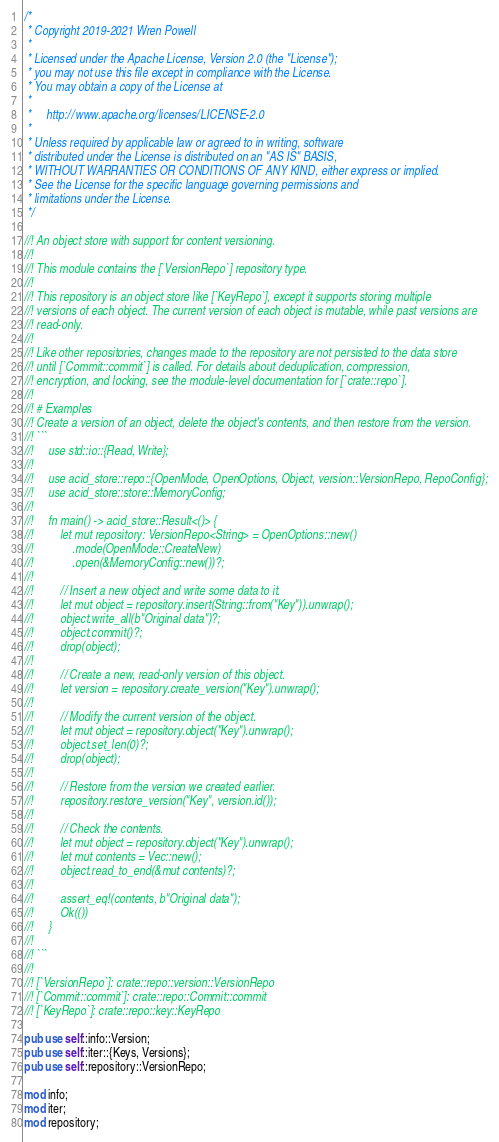Convert code to text. <code><loc_0><loc_0><loc_500><loc_500><_Rust_>/*
 * Copyright 2019-2021 Wren Powell
 *
 * Licensed under the Apache License, Version 2.0 (the "License");
 * you may not use this file except in compliance with the License.
 * You may obtain a copy of the License at
 *
 *     http://www.apache.org/licenses/LICENSE-2.0
 *
 * Unless required by applicable law or agreed to in writing, software
 * distributed under the License is distributed on an "AS IS" BASIS,
 * WITHOUT WARRANTIES OR CONDITIONS OF ANY KIND, either express or implied.
 * See the License for the specific language governing permissions and
 * limitations under the License.
 */

//! An object store with support for content versioning.
//!
//! This module contains the [`VersionRepo`] repository type.
//!
//! This repository is an object store like [`KeyRepo`], except it supports storing multiple
//! versions of each object. The current version of each object is mutable, while past versions are
//! read-only.
//!
//! Like other repositories, changes made to the repository are not persisted to the data store
//! until [`Commit::commit`] is called. For details about deduplication, compression,
//! encryption, and locking, see the module-level documentation for [`crate::repo`].
//!
//! # Examples
//! Create a version of an object, delete the object's contents, and then restore from the version.
//! ```
//!     use std::io::{Read, Write};
//!
//!     use acid_store::repo::{OpenMode, OpenOptions, Object, version::VersionRepo, RepoConfig};
//!     use acid_store::store::MemoryConfig;
//!
//!     fn main() -> acid_store::Result<()> {
//!         let mut repository: VersionRepo<String> = OpenOptions::new()
//!             .mode(OpenMode::CreateNew)
//!             .open(&MemoryConfig::new())?;
//!
//!         // Insert a new object and write some data to it.
//!         let mut object = repository.insert(String::from("Key")).unwrap();
//!         object.write_all(b"Original data")?;
//!         object.commit()?;
//!         drop(object);
//!
//!         // Create a new, read-only version of this object.
//!         let version = repository.create_version("Key").unwrap();
//!
//!         // Modify the current version of the object.
//!         let mut object = repository.object("Key").unwrap();
//!         object.set_len(0)?;
//!         drop(object);
//!
//!         // Restore from the version we created earlier.
//!         repository.restore_version("Key", version.id());
//!
//!         // Check the contents.
//!         let mut object = repository.object("Key").unwrap();
//!         let mut contents = Vec::new();
//!         object.read_to_end(&mut contents)?;
//!
//!         assert_eq!(contents, b"Original data");
//!         Ok(())
//!     }
//!
//! ```
//!
//! [`VersionRepo`]: crate::repo::version::VersionRepo
//! [`Commit::commit`]: crate::repo::Commit::commit
//! [`KeyRepo`]: crate::repo::key::KeyRepo

pub use self::info::Version;
pub use self::iter::{Keys, Versions};
pub use self::repository::VersionRepo;

mod info;
mod iter;
mod repository;
</code> 